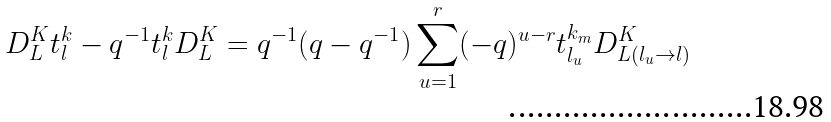<formula> <loc_0><loc_0><loc_500><loc_500>D ^ { K } _ { L } t ^ { k } _ { l } - q ^ { - 1 } t ^ { k } _ { l } D ^ { K } _ { L } = q ^ { - 1 } ( q - q ^ { - 1 } ) \sum _ { u = 1 } ^ { r } ( - q ) ^ { u - r } t ^ { k _ { m } } _ { l _ { u } } D ^ { K } _ { L ( l _ { u } \rightarrow l ) }</formula> 